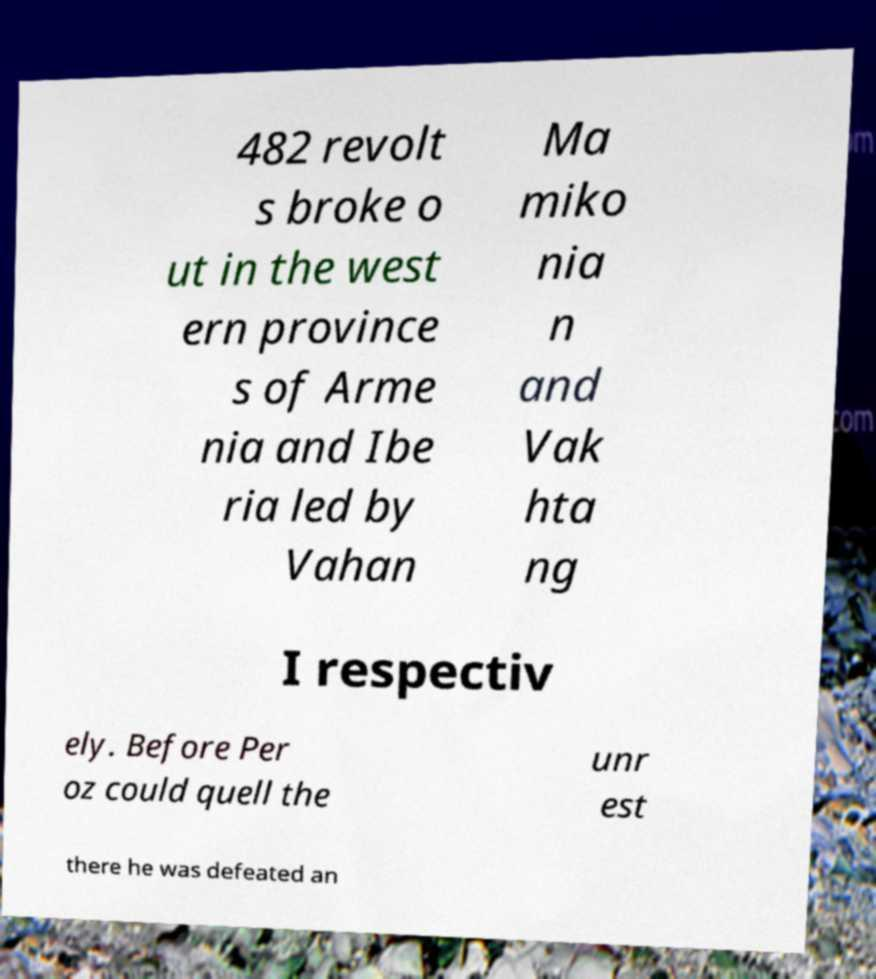What messages or text are displayed in this image? I need them in a readable, typed format. 482 revolt s broke o ut in the west ern province s of Arme nia and Ibe ria led by Vahan Ma miko nia n and Vak hta ng I respectiv ely. Before Per oz could quell the unr est there he was defeated an 